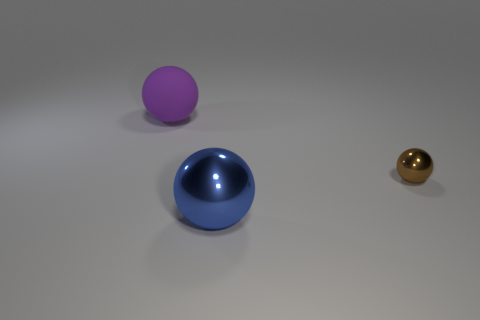What color is the sphere in front of the shiny sphere that is behind the big object that is in front of the big matte thing? blue 